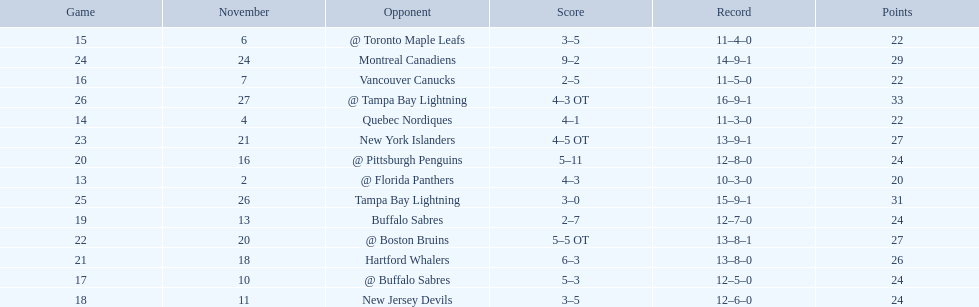Who are all of the teams? @ Florida Panthers, Quebec Nordiques, @ Toronto Maple Leafs, Vancouver Canucks, @ Buffalo Sabres, New Jersey Devils, Buffalo Sabres, @ Pittsburgh Penguins, Hartford Whalers, @ Boston Bruins, New York Islanders, Montreal Canadiens, Tampa Bay Lightning. What games finished in overtime? 22, 23, 26. In game number 23, who did they face? New York Islanders. 